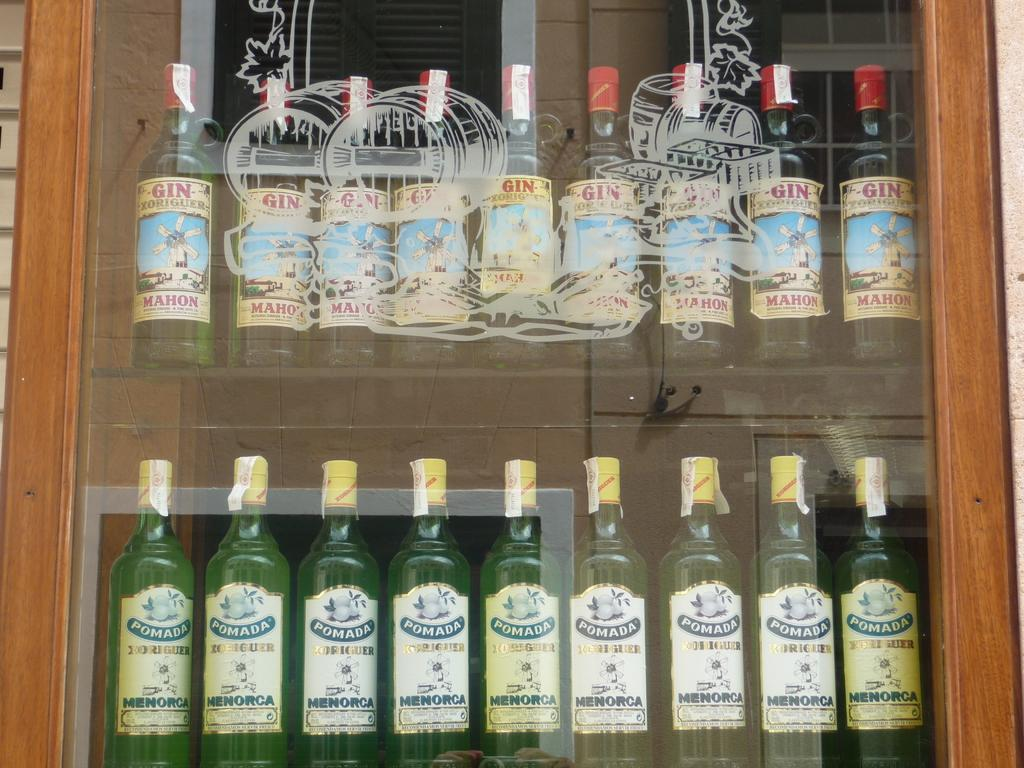What type of door is visible in the image? There is a glass door in the image. Is there anything on the glass door? Yes, the glass door has a sticker on it. What else can be seen in the image besides the door? There are bottles in the image. How are the bottles arranged? The bottles are arranged in an order. Can you tell me how many visitors are waiting outside the grandmother's store in the image? There is no mention of a grandmother or a store in the image, and no visitors are visible. 